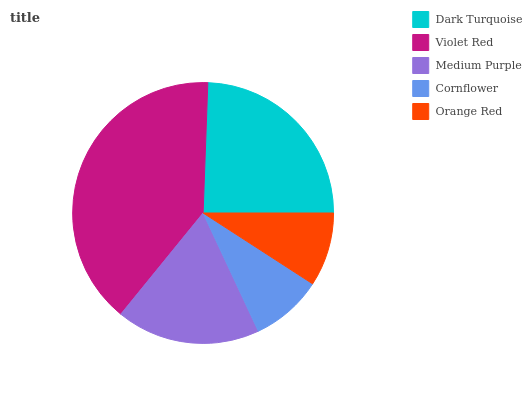Is Cornflower the minimum?
Answer yes or no. Yes. Is Violet Red the maximum?
Answer yes or no. Yes. Is Medium Purple the minimum?
Answer yes or no. No. Is Medium Purple the maximum?
Answer yes or no. No. Is Violet Red greater than Medium Purple?
Answer yes or no. Yes. Is Medium Purple less than Violet Red?
Answer yes or no. Yes. Is Medium Purple greater than Violet Red?
Answer yes or no. No. Is Violet Red less than Medium Purple?
Answer yes or no. No. Is Medium Purple the high median?
Answer yes or no. Yes. Is Medium Purple the low median?
Answer yes or no. Yes. Is Dark Turquoise the high median?
Answer yes or no. No. Is Dark Turquoise the low median?
Answer yes or no. No. 